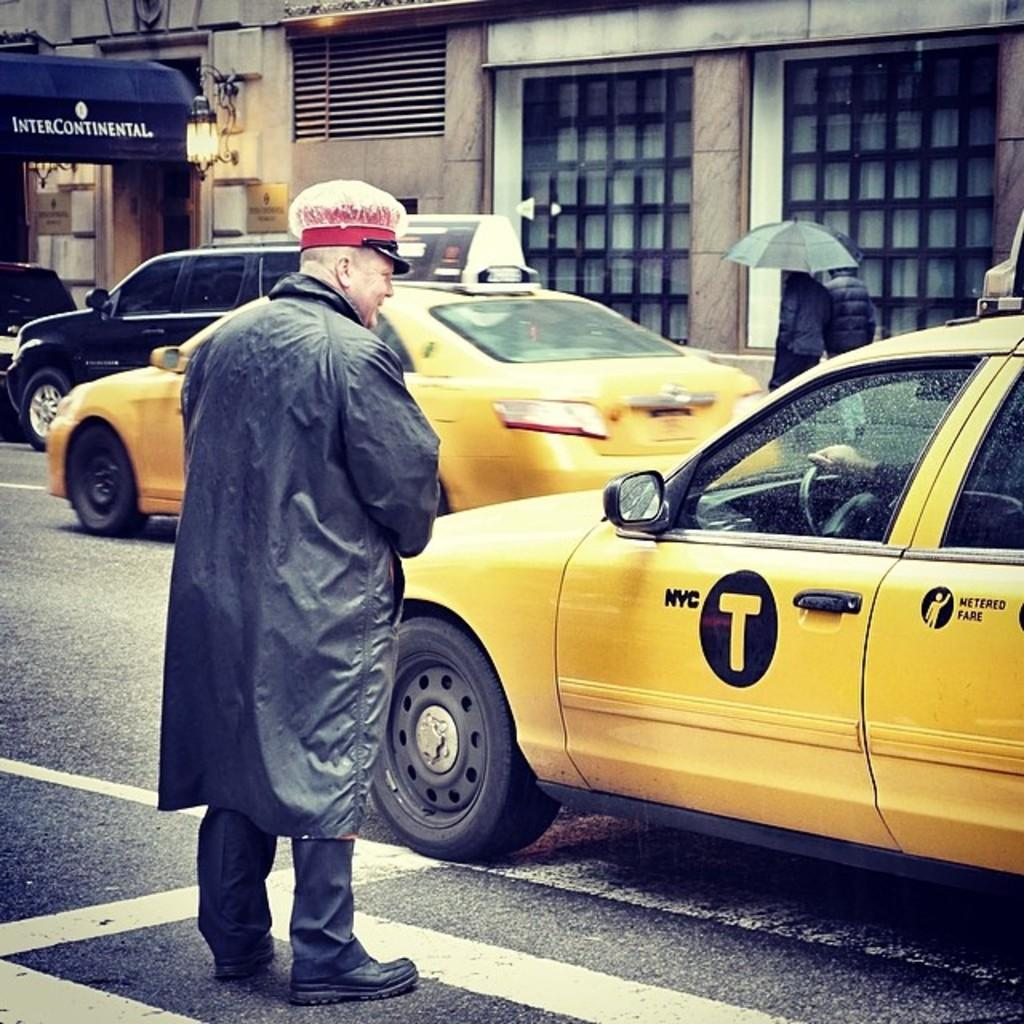<image>
Provide a brief description of the given image. A man with a hat standing outside of an NYC taxi 